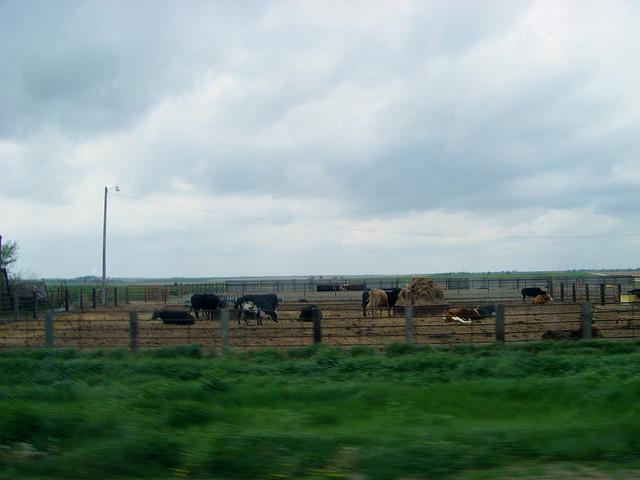What type of animal is this?
Write a very short answer. Cow. Is the grass moist or dry?
Keep it brief. Moist. Is the object in the sky a bird?
Answer briefly. No. Is there shrubbery in the front?
Concise answer only. No. Is the ground damp?
Write a very short answer. No. Is this animal in the wild?
Concise answer only. No. How many animals are seen?
Keep it brief. 10. What structure is behind the tree?
Short answer required. Fence. Is there a watering hole?
Give a very brief answer. No. What is the weather like?
Quick response, please. Cloudy. How many animals are in this photo?
Answer briefly. 10. Are there kites in the sky?
Be succinct. No. What is the fence made of?
Answer briefly. Metal. Are the animals in a wooded area?
Concise answer only. No. How many barns can be seen?
Be succinct. 0. What kind of weather is this?
Answer briefly. Cloudy. What animal is this?
Write a very short answer. Cows. Are the animals in the brush?
Quick response, please. No. What is at the bottom center of the photo?
Concise answer only. Grass. Is it rainy or sunny?
Give a very brief answer. Rainy. Are there mountains in the background?
Give a very brief answer. No. What is the sun shining through?
Answer briefly. Clouds. Is the ground flat?
Write a very short answer. Yes. Is it a sunny day?
Give a very brief answer. No. Is there a city in the background?
Keep it brief. No. Which animal is shown in the picture?
Write a very short answer. Cows. What kind of animal is this?
Short answer required. Cow. Where is the bull?
Answer briefly. Pen. Where are the animals located?
Answer briefly. Farm. What is the fencing made of?
Concise answer only. Wood. What animal besides cow is in the picture?
Be succinct. Horse. Could this be a photo shoot?
Write a very short answer. No. Is that a kids playspace?
Short answer required. No. Could this be a park?
Quick response, please. No. Where is the brown cow?
Give a very brief answer. In background. Are there clouds in the sky?
Write a very short answer. Yes. Why are the animals there?
Write a very short answer. Farm. What color is the fence?
Answer briefly. Gray. Do these animals require a person to deliver food to them daily?
Short answer required. Yes. What is the color of the hydrant?
Quick response, please. No hydrant. What are the cows grazing on?
Keep it brief. Grass. How many mountains are there?
Quick response, please. 0. Is the fence broken?
Be succinct. No. Which animal is this?
Give a very brief answer. Cow. Where is the bird?
Keep it brief. Nowhere. Is there any big trees around?
Quick response, please. No. 